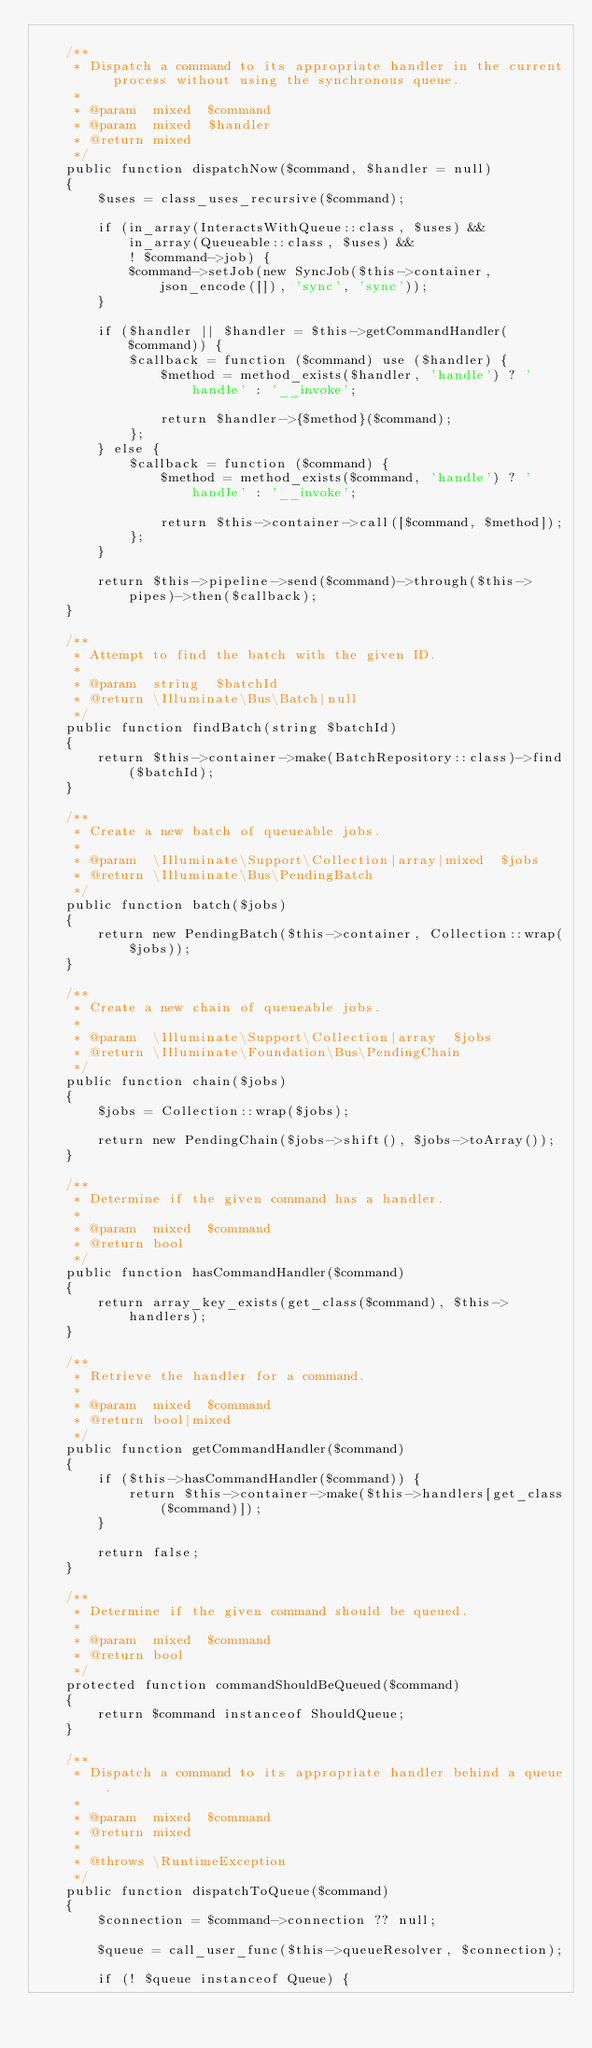<code> <loc_0><loc_0><loc_500><loc_500><_PHP_>
    /**
     * Dispatch a command to its appropriate handler in the current process without using the synchronous queue.
     *
     * @param  mixed  $command
     * @param  mixed  $handler
     * @return mixed
     */
    public function dispatchNow($command, $handler = null)
    {
        $uses = class_uses_recursive($command);

        if (in_array(InteractsWithQueue::class, $uses) &&
            in_array(Queueable::class, $uses) &&
            ! $command->job) {
            $command->setJob(new SyncJob($this->container, json_encode([]), 'sync', 'sync'));
        }

        if ($handler || $handler = $this->getCommandHandler($command)) {
            $callback = function ($command) use ($handler) {
                $method = method_exists($handler, 'handle') ? 'handle' : '__invoke';

                return $handler->{$method}($command);
            };
        } else {
            $callback = function ($command) {
                $method = method_exists($command, 'handle') ? 'handle' : '__invoke';

                return $this->container->call([$command, $method]);
            };
        }

        return $this->pipeline->send($command)->through($this->pipes)->then($callback);
    }

    /**
     * Attempt to find the batch with the given ID.
     *
     * @param  string  $batchId
     * @return \Illuminate\Bus\Batch|null
     */
    public function findBatch(string $batchId)
    {
        return $this->container->make(BatchRepository::class)->find($batchId);
    }

    /**
     * Create a new batch of queueable jobs.
     *
     * @param  \Illuminate\Support\Collection|array|mixed  $jobs
     * @return \Illuminate\Bus\PendingBatch
     */
    public function batch($jobs)
    {
        return new PendingBatch($this->container, Collection::wrap($jobs));
    }

    /**
     * Create a new chain of queueable jobs.
     *
     * @param  \Illuminate\Support\Collection|array  $jobs
     * @return \Illuminate\Foundation\Bus\PendingChain
     */
    public function chain($jobs)
    {
        $jobs = Collection::wrap($jobs);

        return new PendingChain($jobs->shift(), $jobs->toArray());
    }

    /**
     * Determine if the given command has a handler.
     *
     * @param  mixed  $command
     * @return bool
     */
    public function hasCommandHandler($command)
    {
        return array_key_exists(get_class($command), $this->handlers);
    }

    /**
     * Retrieve the handler for a command.
     *
     * @param  mixed  $command
     * @return bool|mixed
     */
    public function getCommandHandler($command)
    {
        if ($this->hasCommandHandler($command)) {
            return $this->container->make($this->handlers[get_class($command)]);
        }

        return false;
    }

    /**
     * Determine if the given command should be queued.
     *
     * @param  mixed  $command
     * @return bool
     */
    protected function commandShouldBeQueued($command)
    {
        return $command instanceof ShouldQueue;
    }

    /**
     * Dispatch a command to its appropriate handler behind a queue.
     *
     * @param  mixed  $command
     * @return mixed
     *
     * @throws \RuntimeException
     */
    public function dispatchToQueue($command)
    {
        $connection = $command->connection ?? null;

        $queue = call_user_func($this->queueResolver, $connection);

        if (! $queue instanceof Queue) {</code> 